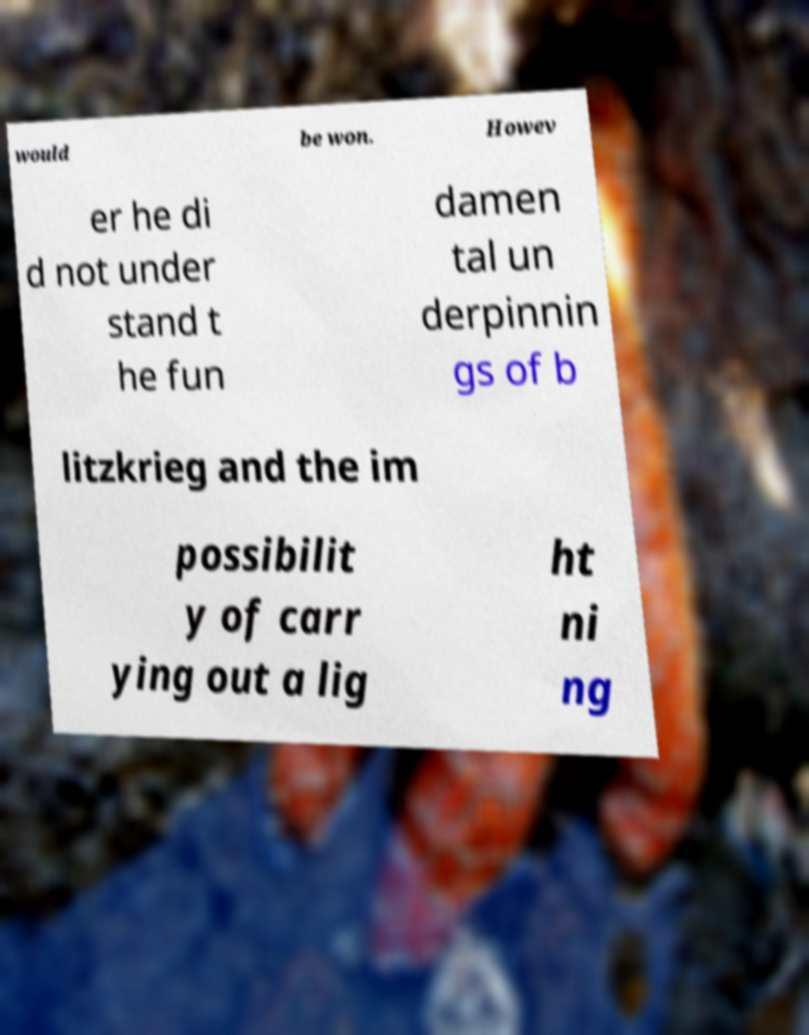Please read and relay the text visible in this image. What does it say? would be won. Howev er he di d not under stand t he fun damen tal un derpinnin gs of b litzkrieg and the im possibilit y of carr ying out a lig ht ni ng 